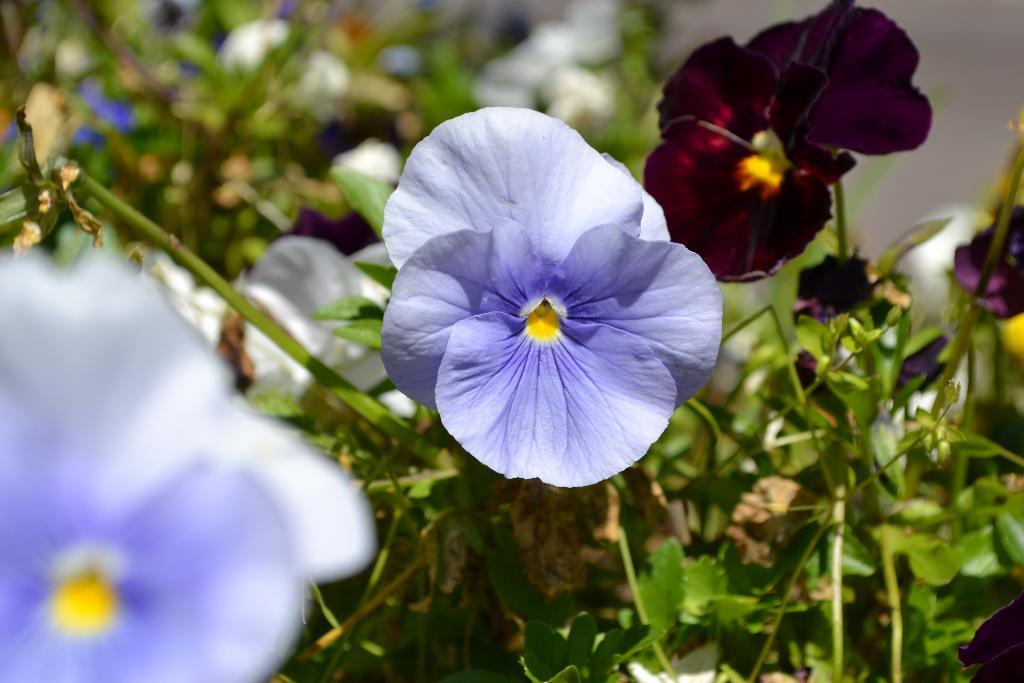What colors are the flowers on the plant in the image? There is a blue flower and a red flower on the plant in the image. Where are most of the flowers located on the plant? Most of the flowers are on the left side of the image. What can be seen in the bottom right corner of the image? There are leaves visible in the bottom right corner of the image. What type of brass instrument is being played in the image? There is no brass instrument or any musical instrument present in the image; it features a plant with flowers. 